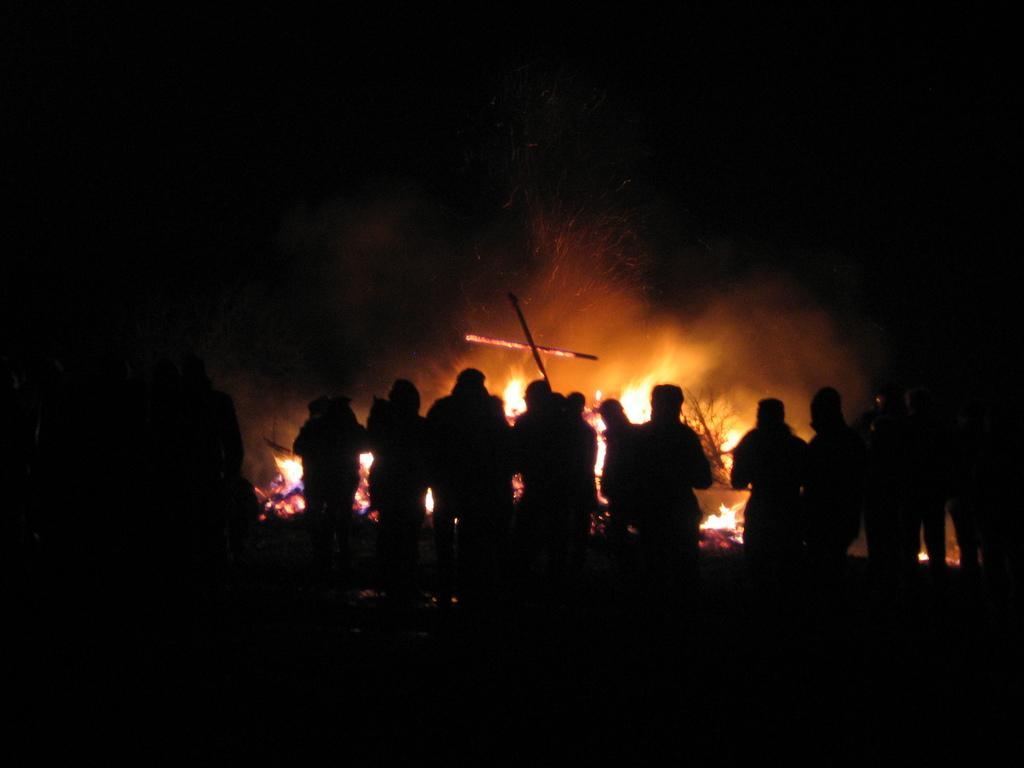Please provide a concise description of this image. In this picture I can see group of people standing, there is fire behind the people, and there is dark background. 